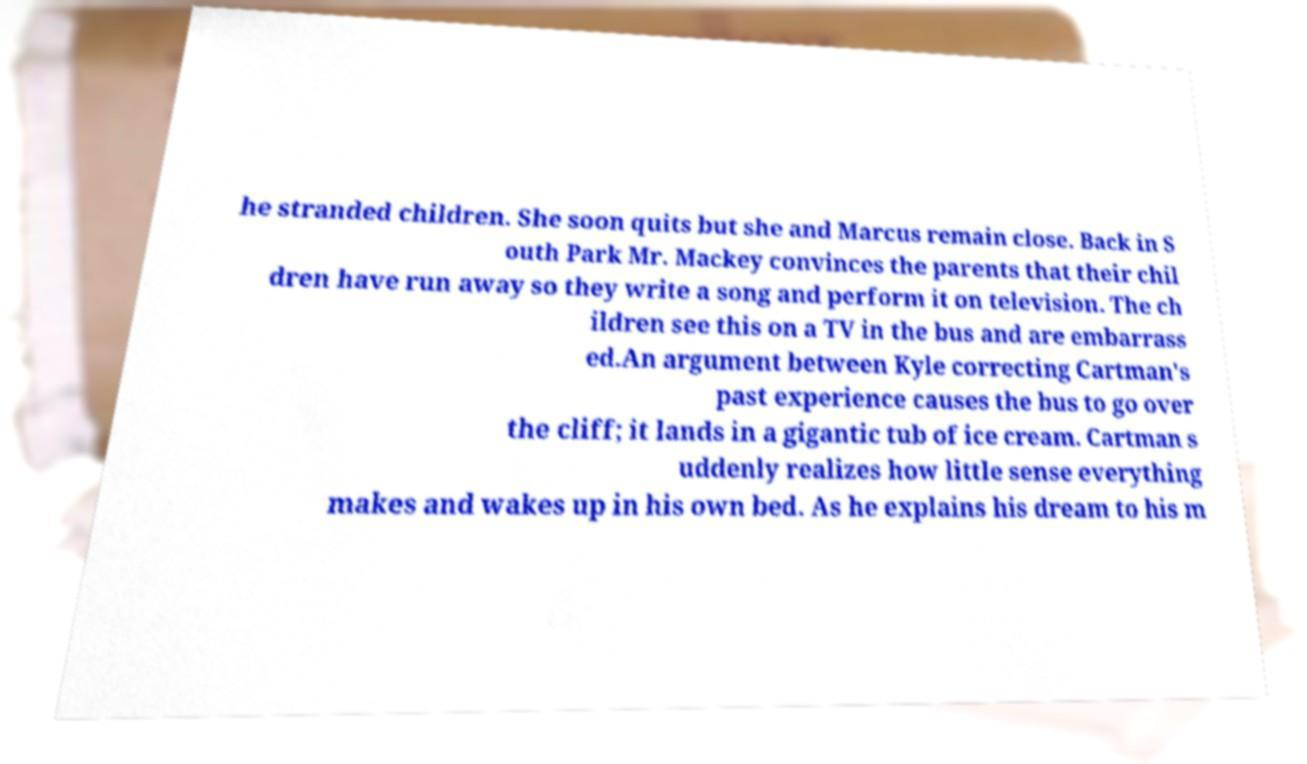There's text embedded in this image that I need extracted. Can you transcribe it verbatim? he stranded children. She soon quits but she and Marcus remain close. Back in S outh Park Mr. Mackey convinces the parents that their chil dren have run away so they write a song and perform it on television. The ch ildren see this on a TV in the bus and are embarrass ed.An argument between Kyle correcting Cartman's past experience causes the bus to go over the cliff; it lands in a gigantic tub of ice cream. Cartman s uddenly realizes how little sense everything makes and wakes up in his own bed. As he explains his dream to his m 